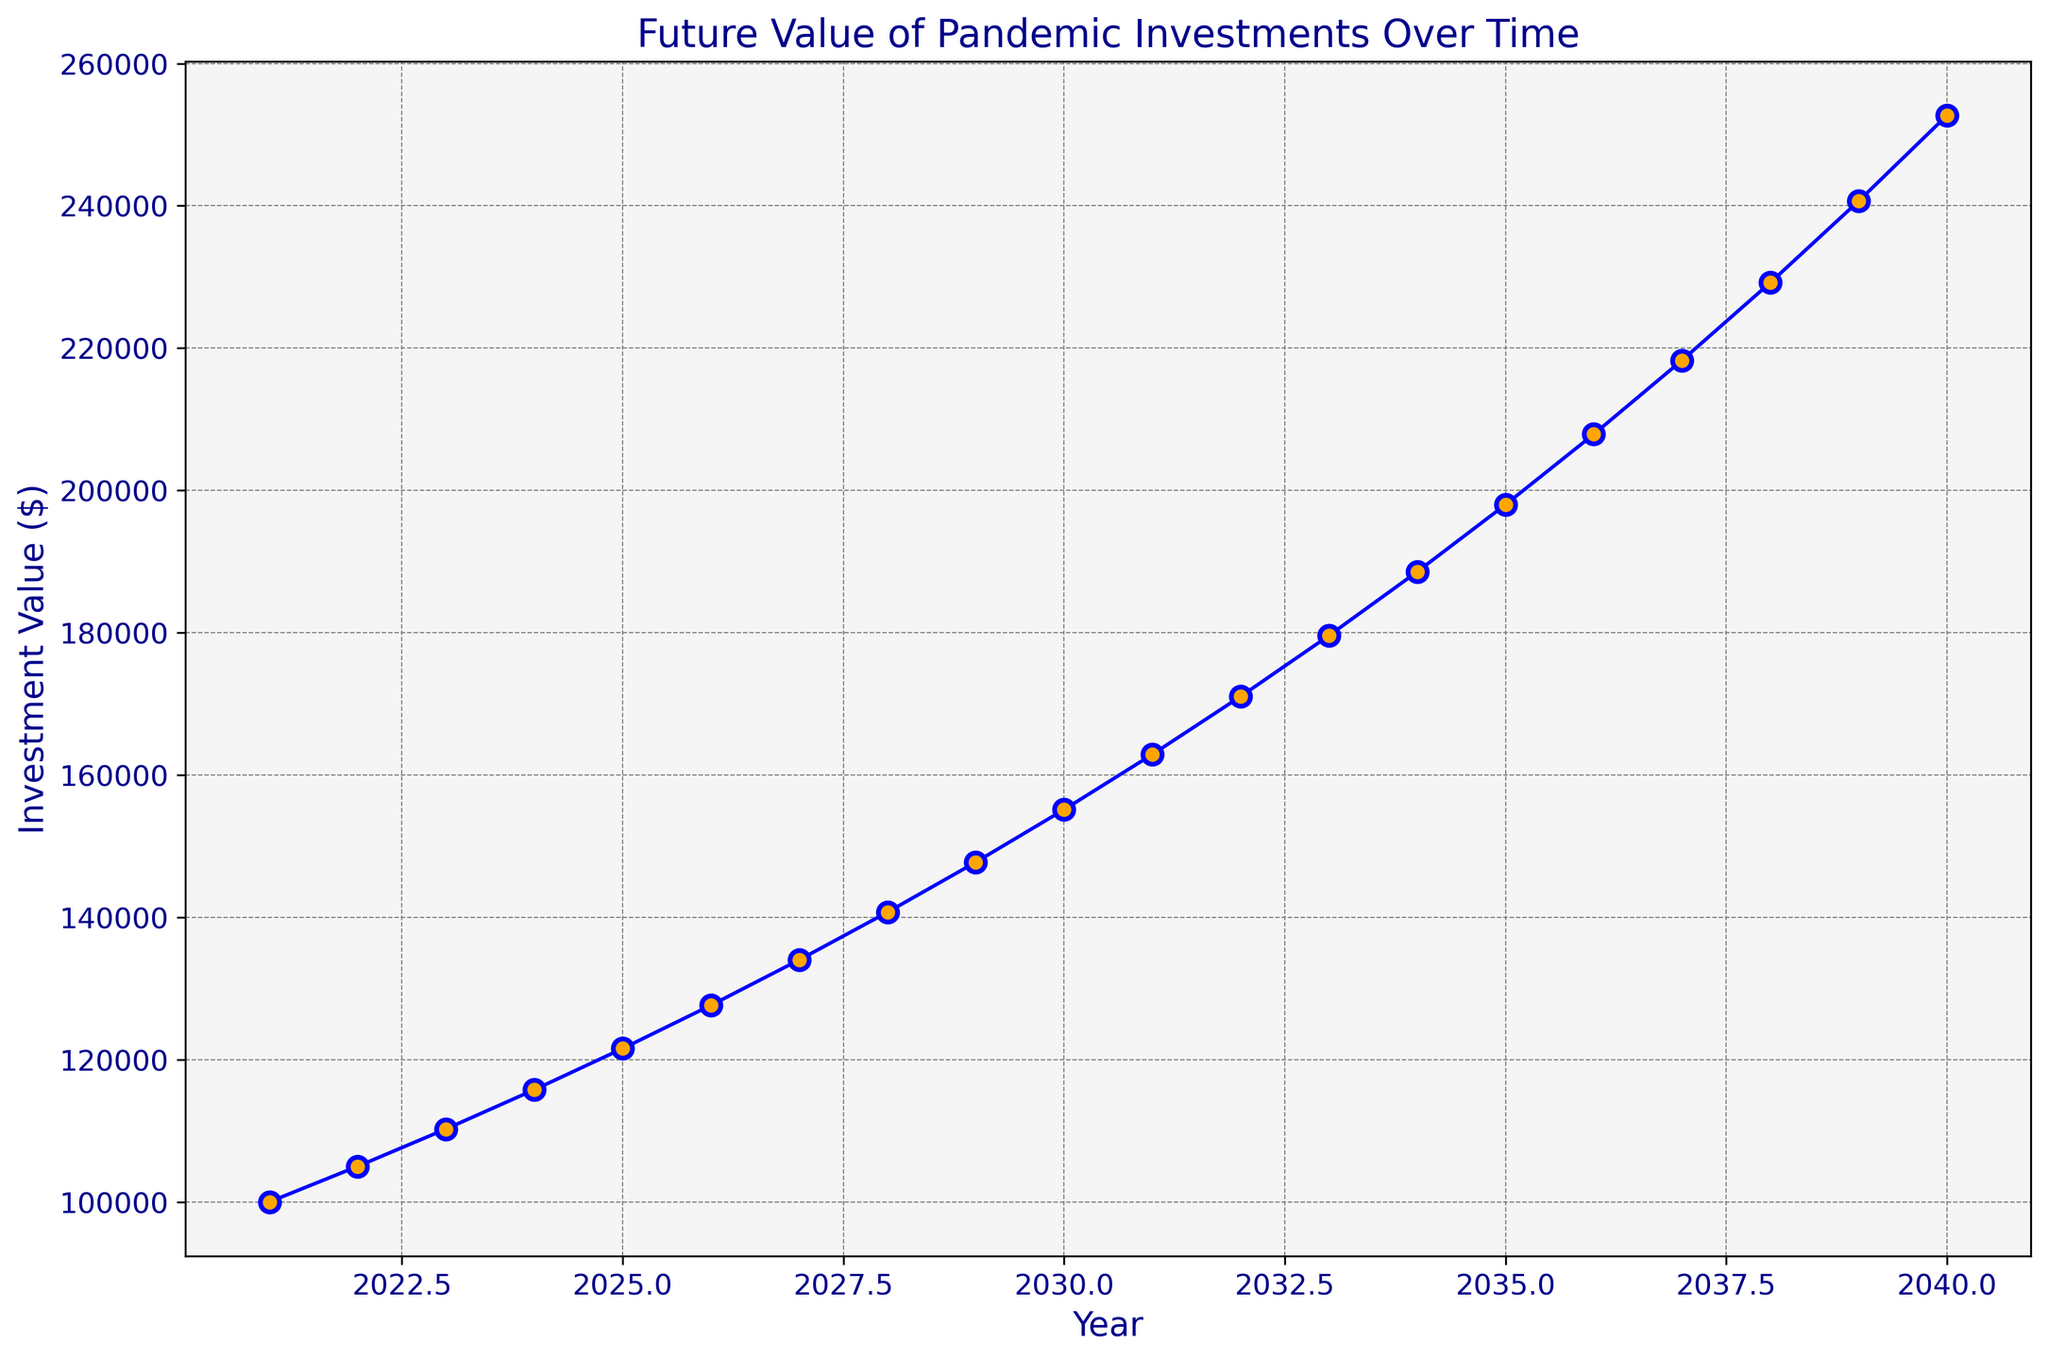What's the investment value in the year 2030? To find the investment value in 2030, look at the point on the plot where the year is 2030 and observe the corresponding investment value on the y-axis. The investment value for 2030 is indicated as $155,133.
Answer: $155,133 How much does the investment value increase between 2025 and 2030? Find the investment values for the years 2025 and 2030 from the plot. The value in 2025 is $121,551, and in 2030, it is $155,133. Subtract the 2025 value from the 2030 value: $155,133 - $121,551 = $33,582.
Answer: $33,582 Which year has the highest investment value according to the plot? Observe the trend and endpoints of the plot to identify the year with the highest investment value. The latest year, 2040, shows the highest value at $252,694 according to the trend.
Answer: 2040 By how much does the investment value grow from 2027 to 2029? Retrieve the investment values for 2027 ($134,010) and 2029 ($147,746) from the plot. Calculate the difference: $147,746 - $134,010 = $13,736.
Answer: $13,736 What is the average investment value from 2021 to 2025? Find the investment values for each year from 2021 to 2025 from the plot: 2021 ($100,000), 2022 ($105,000), 2023 ($110,250), 2024 ($115,763), 2025 ($121,551). Sum them up and divide by the number of years: ($100,000 + $105,000 + $110,250 + $115,763 + $121,551) / 5 = $110,912.8.
Answer: $110,912.8 What is the color used for the line and the markers in the plot? Observe the colors used in the plot for both the line and the markers. The line is colored blue, and the markers are orange.
Answer: Blue for the line, orange for the markers How many units does the investment value increase between the peak points of 2024 and 2037? Find the investment values for the years 2024 ($115,763) and 2037 ($218,287). Subtract the 2024 value from the 2037 value: $218,287 - $115,763 = $102,524.
Answer: $102,524 